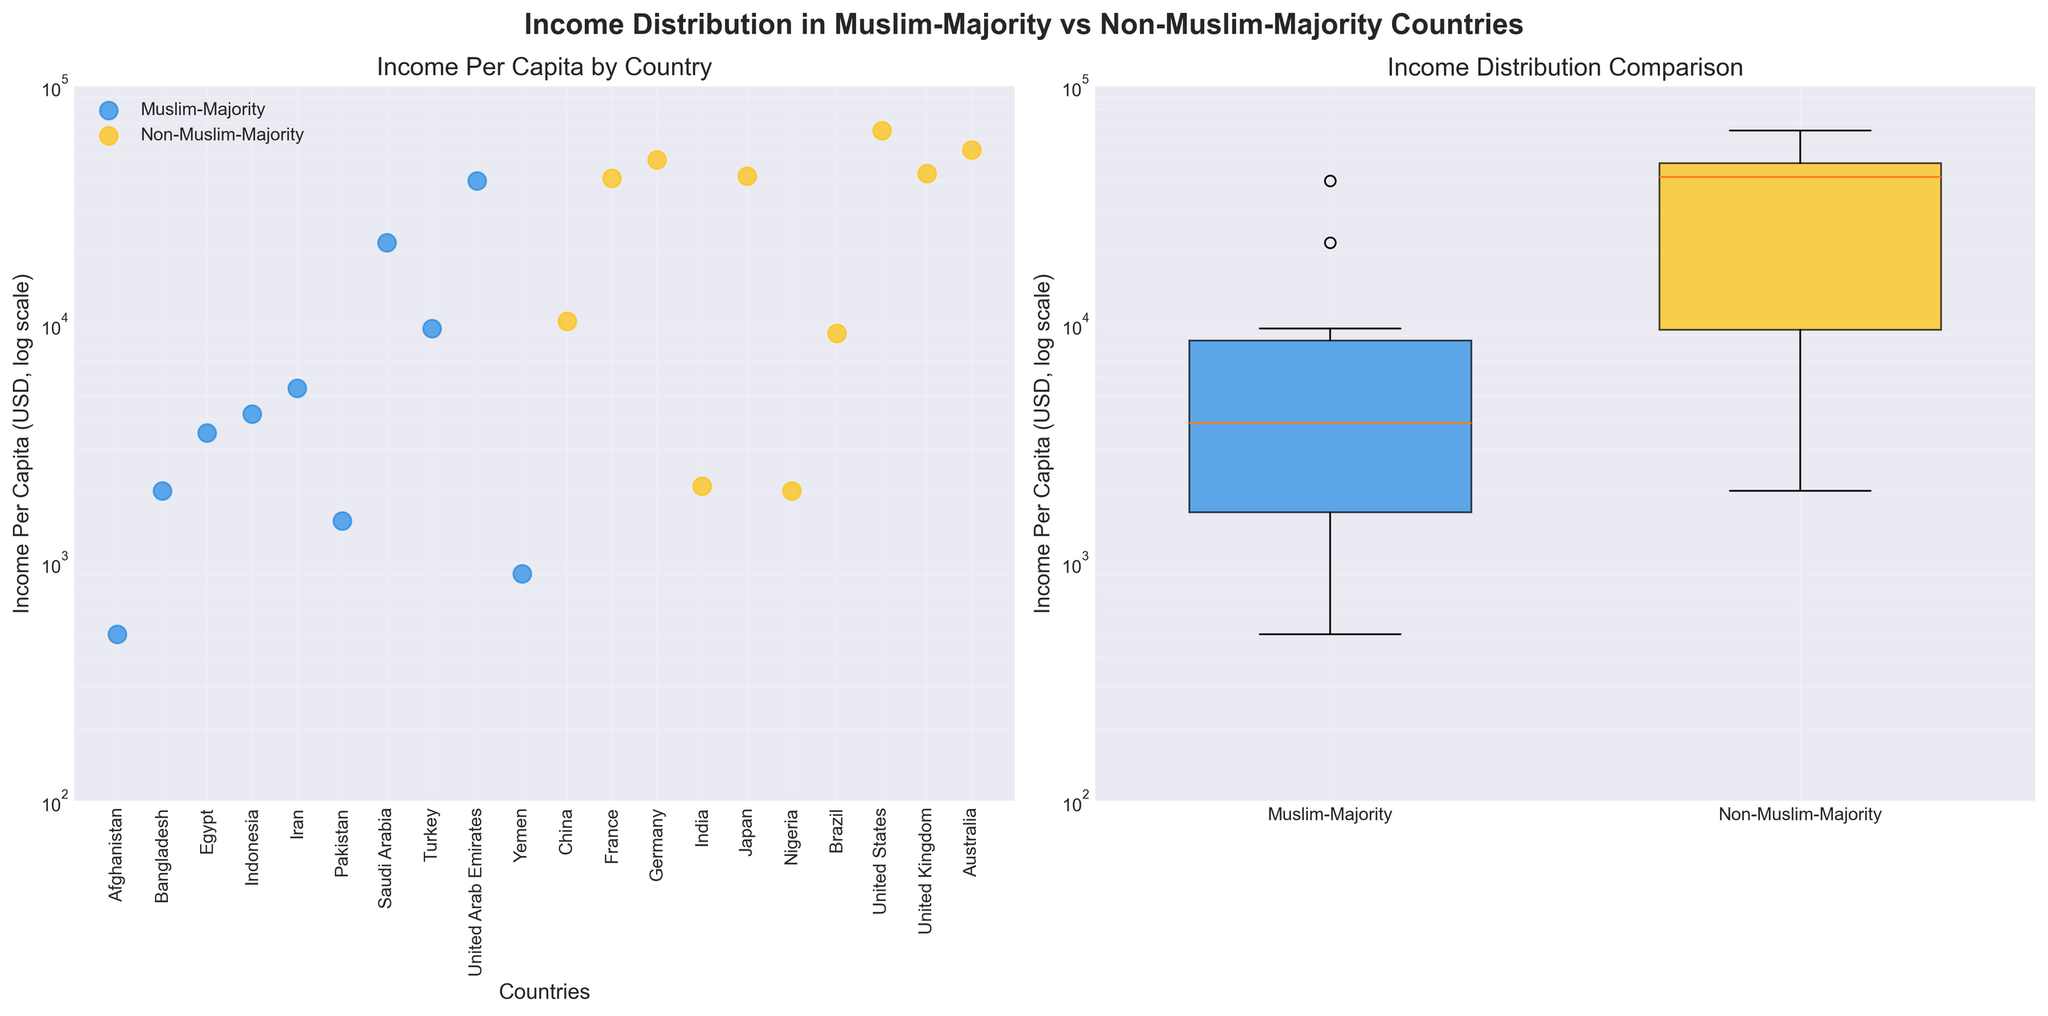What's the title of the figure? The figure's title is displayed prominently at the top. It reads "Income Distribution in Muslim-Majority vs Non-Muslim-Majority Countries".
Answer: Income Distribution in Muslim-Majority vs Non-Muslim-Majority Countries How many countries are displayed in the scatter plot on the left? The scatter plot displays each country as a data point. By counting the dots, we see there are 18 countries.
Answer: 18 Which country has the highest income per capita among Muslim-majority countries? By looking at the scatter plot on the left, we can see that the highest dot for Muslim-majority countries is labeled "United Arab Emirates".
Answer: United Arab Emirates What is the income per capita of the country with the lowest income per capita among non-Muslim-majority countries? By examining the scatter plot for non-Muslim-majority countries, the lowest dot corresponds to Nigeria, which has an income per capita of 2,000 USD.
Answer: 2,000 USD Which income group has the most representation among Muslim-majority countries in the scatter plot? By examining the labels on the x-axis and their categorization, we can see that most Muslim-majority countries fall into the "Lower_Middle" income group.
Answer: Lower_Middle On the boxplot, which group has a wider range of income per capita, Muslim-majority or non-Muslim-majority countries? By comparing the vertical span of the box and whiskers in the boxplot, we can see that non-Muslim-majority countries have a wider range.
Answer: Non-Muslim-majority countries What is the approximate income per capita of Turkey in the scatter plot? By locating Turkey on the x-axis of the scatter plot and checking its position on the y-axis, we see that it is approximately 9,600 USD.
Answer: 9,600 USD Which group has the highest median income per capita according to the boxplot? In the boxplot, the median is represented by the horizontal line inside each box. The median line is higher for non-Muslim-majority countries.
Answer: Non-Muslim-majority countries Is the distribution of income per capita skewed in Muslim-majority countries? If so, in which direction? Observing the scatter plot and the boxplot, most of the data points are clustered towards the lower income range with some extremely high values, indicating a positive skew.
Answer: Positive skew What are the two countries with the highest income per capita, and which group do they belong to? From the scatter plot, the two highest points are the United States (65,000 USD) and Australia (54,000 USD), both belonging to non-Muslim-majority countries.
Answer: United States and Australia, Non-Muslim-majority countries 